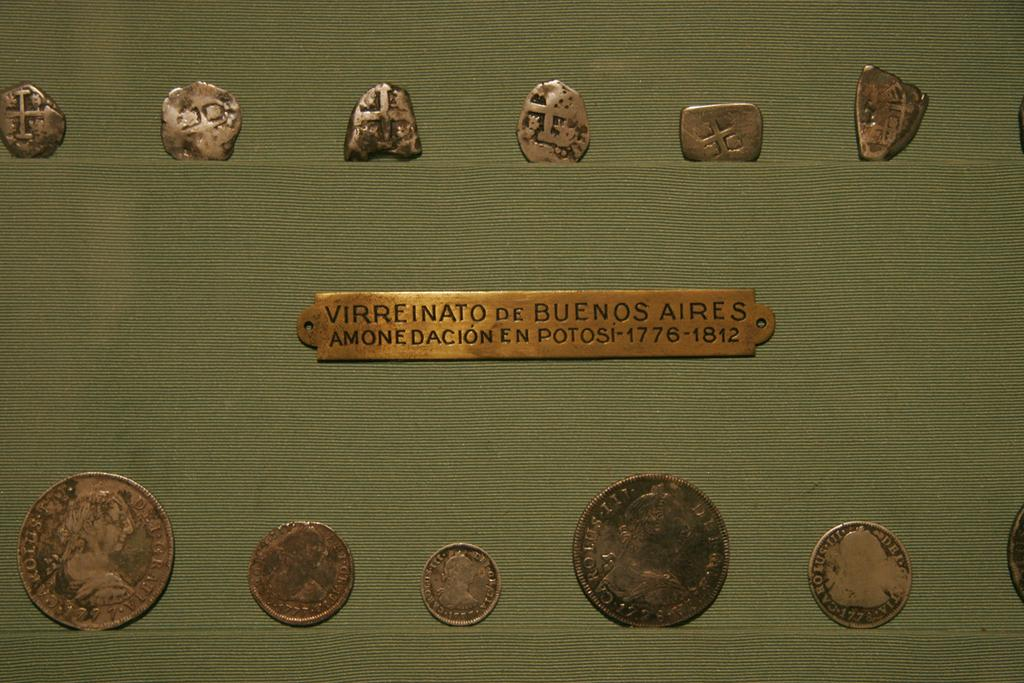<image>
Summarize the visual content of the image. coins around a gold plaque that says virreinato de buenos aires 